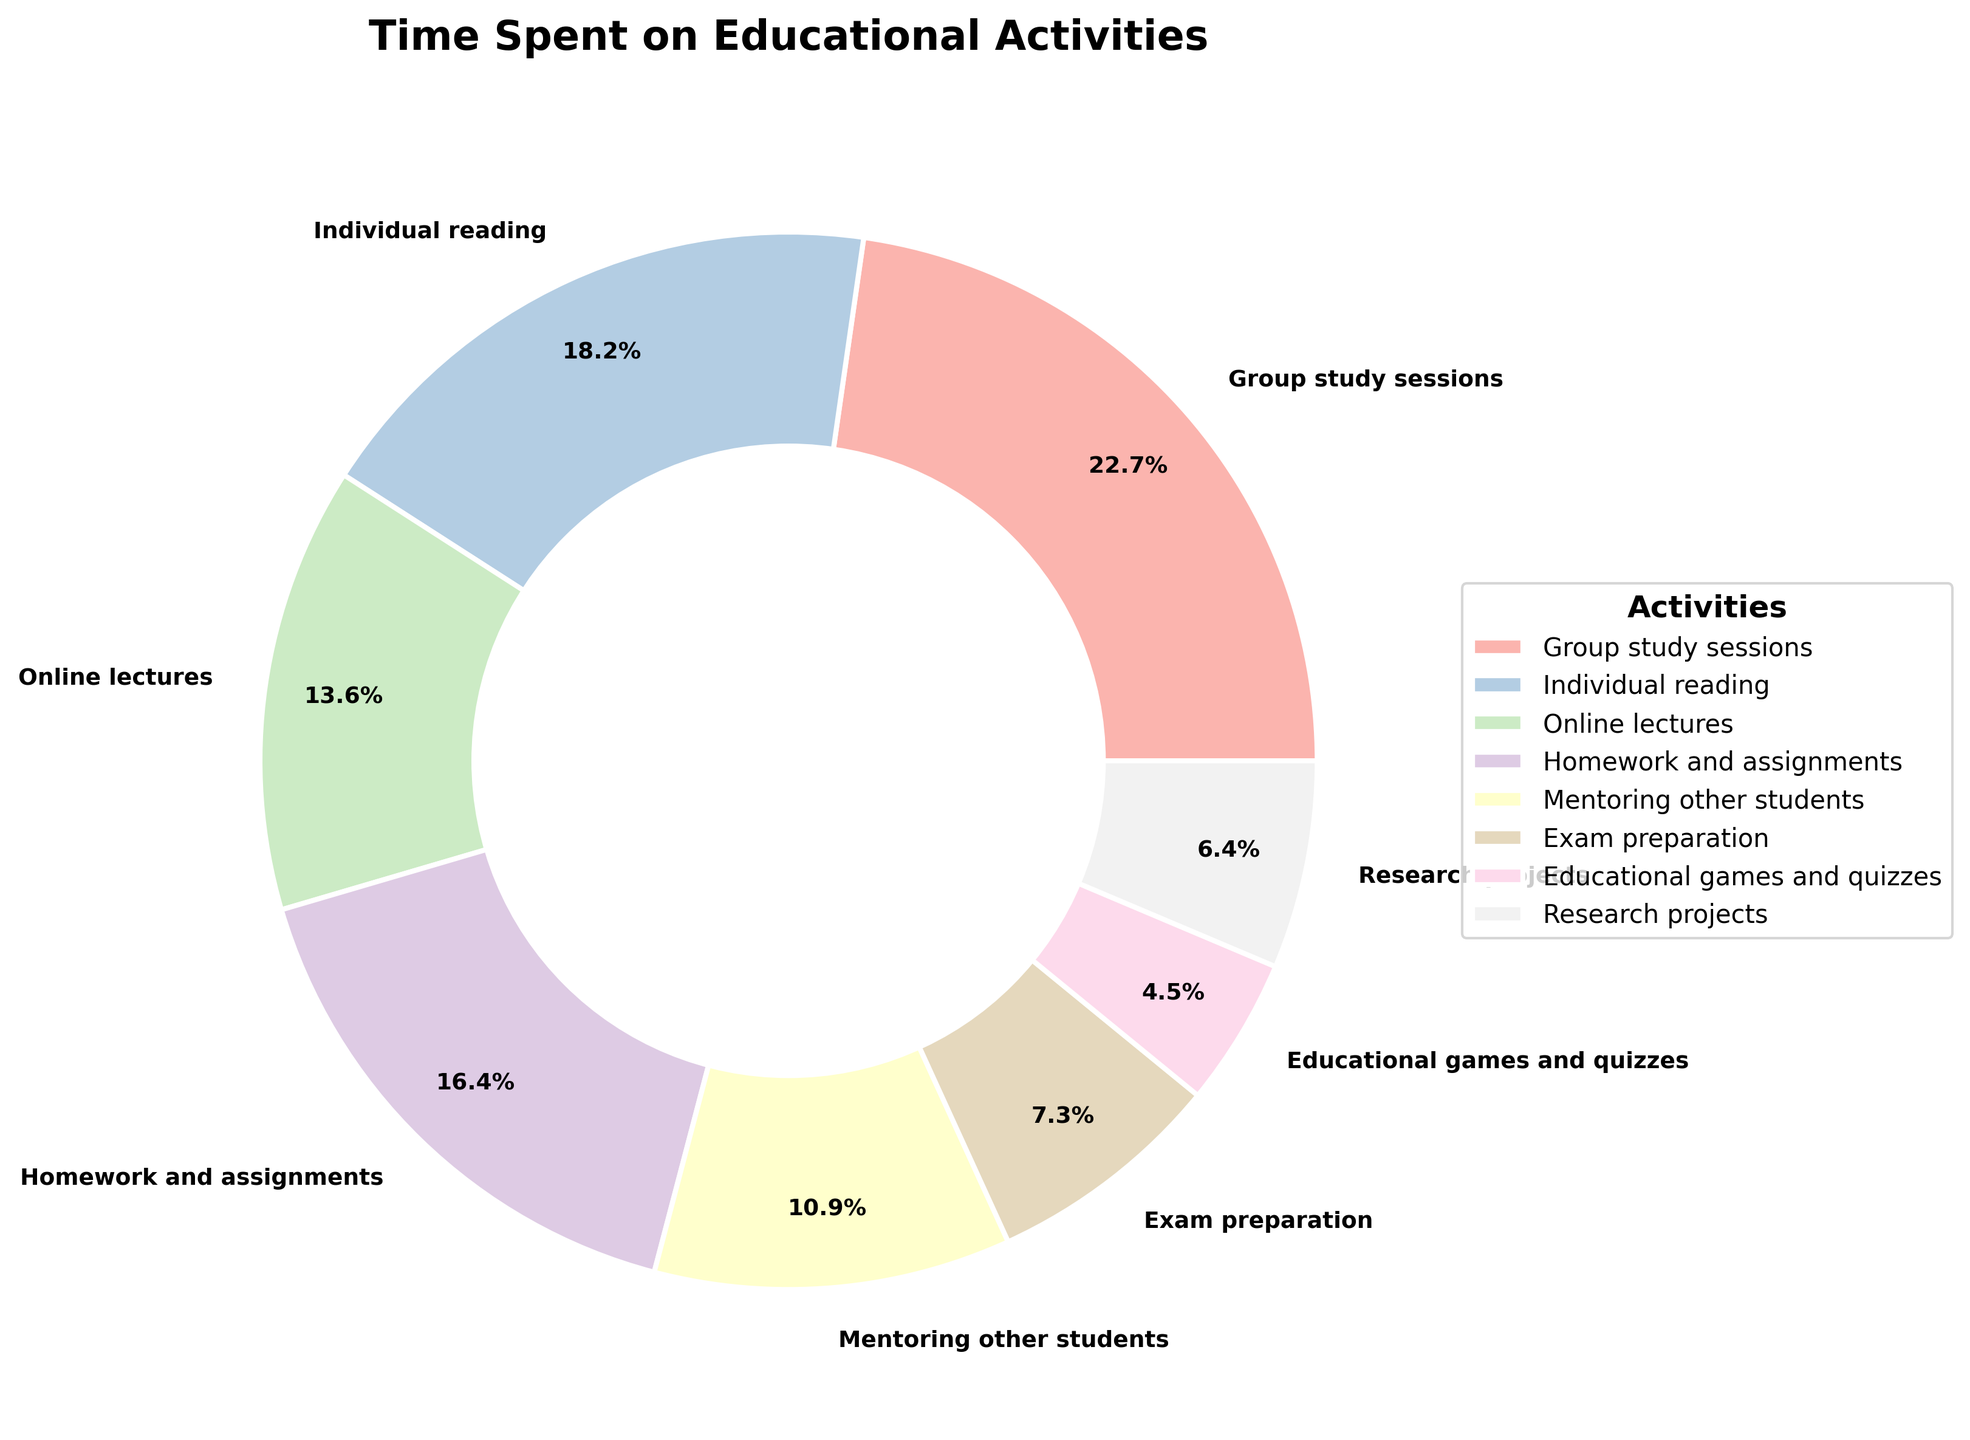What's the activity with the highest percentage of time spent? To find this, look at the pie chart and identify the segment with the largest area and its corresponding label. Group study sessions is the largest segment.
Answer: Group study sessions Which two activities have a combined percentage equal to 32%? Identify the activities and their percentages in the pie chart that sum up to 32%. Mentoring other students (12%) and Homework and assignments (18%) together sum up to 30%, so add Educational games and quizzes (5%) for a total of 32%.
Answer: Mentoring other students and Educational games and quizzes Which activity has a smaller percentage of time spent, Research projects or Online lectures? Compare the segments labeled Research projects (7%) and Online lectures (15%) in the pie chart. Research projects have a smaller percentage.
Answer: Research projects What is the total percentage for Online lectures and Individual reading combined? To find this, add the percentages for Online lectures (15%) and Individual reading (20%). 15% + 20% = 35%.
Answer: 35% By how much does the percentage of Group study sessions exceed the percentage of Exam preparation? Subtract the percentage for Exam preparation (8%) from the percentage for Group study sessions (25%). 25% - 8% = 17%.
Answer: 17% Identify the activity represented by the segment that is light blue. Examine the pie chart and locate the segment colored light blue. The label associated with this segment will correspond to the activity.
Answer: Educational games and quizzes List all activities whose segments account for less than 10% each. Look for segments in the pie chart that is labeled with less than 10%. These activities are: Exam preparation (8%), Educational games and quizzes (5%), and Research projects (7%).
Answer: Exam preparation, Educational games and quizzes, Research projects Which activities combined represent exactly half of the total time spent? Find combinations of activities whose total percentages equal 50%. Group study sessions (25%) and Individual reading (20%) together make 45%, so add Research projects (7%) to get exactly 50%.
Answer: Group study sessions, Individual reading, and Research projects Which segment is larger, Mentoring other students or Homework and assignments? Compare the segments for Mentoring other students (12%) and Homework and assignments (18%). The Homework and assignments segment is larger.
Answer: Homework and assignments 